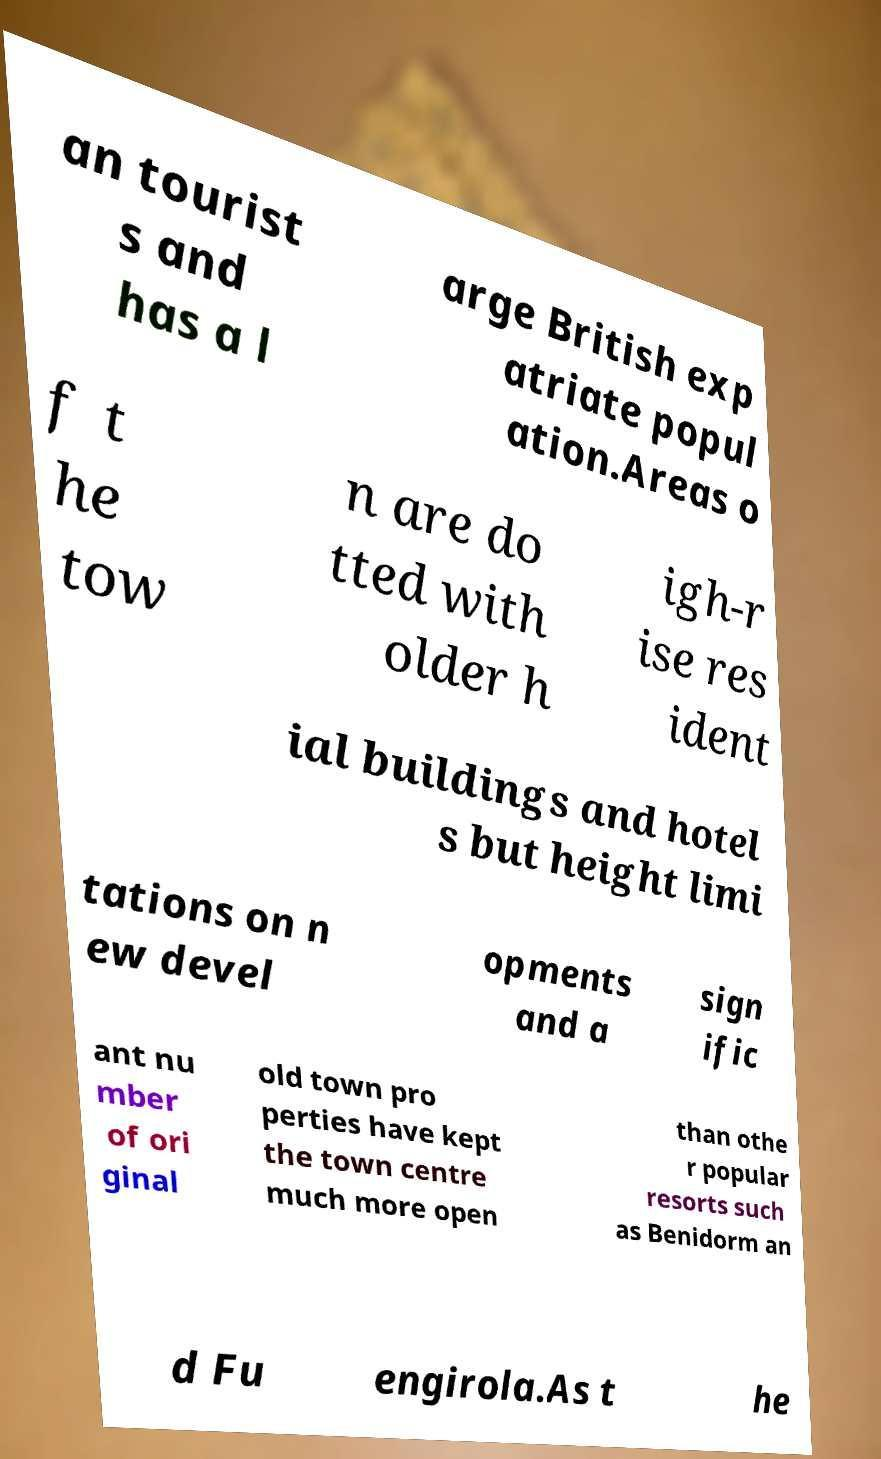Please identify and transcribe the text found in this image. an tourist s and has a l arge British exp atriate popul ation.Areas o f t he tow n are do tted with older h igh-r ise res ident ial buildings and hotel s but height limi tations on n ew devel opments and a sign ific ant nu mber of ori ginal old town pro perties have kept the town centre much more open than othe r popular resorts such as Benidorm an d Fu engirola.As t he 